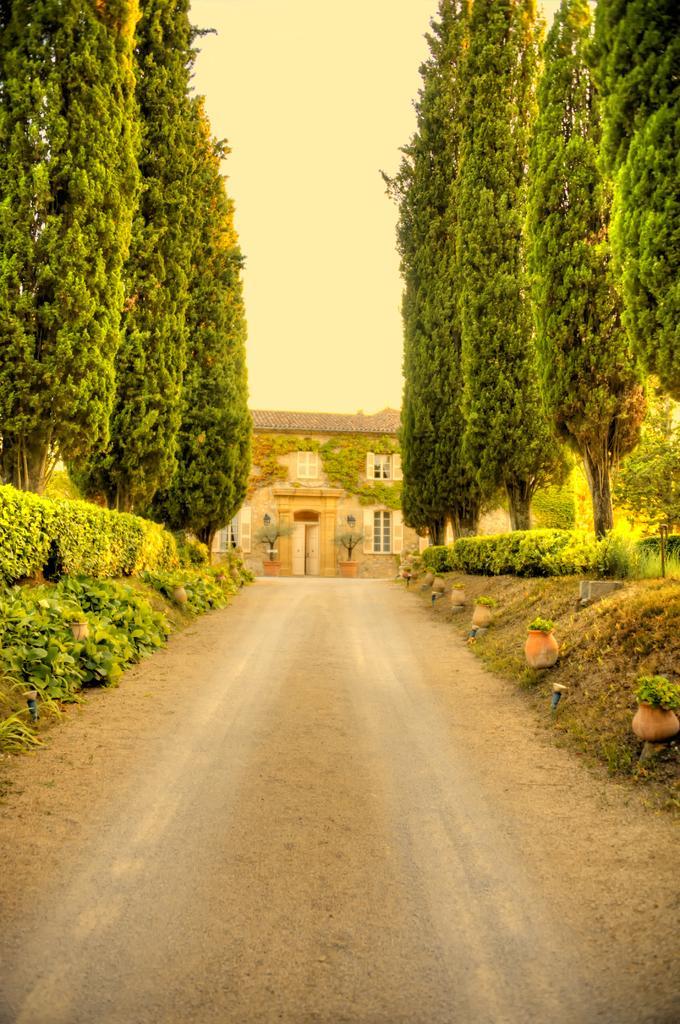Describe this image in one or two sentences. In the center of the image we can see a house, windows, door, wall, pots, trees, bushes are there. At the bottom of the image road is there. At the top of the image sky is there. 